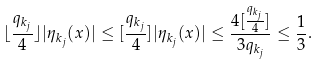Convert formula to latex. <formula><loc_0><loc_0><loc_500><loc_500>\lfloor \frac { q _ { k _ { j } } } { 4 } \rfloor | \eta _ { k _ { j } } ( x ) | \leq [ \frac { q _ { k _ { j } } } { 4 } ] | \eta _ { k _ { j } } ( x ) | \leq \frac { 4 [ \frac { q _ { k _ { j } } } { 4 } ] } { 3 q _ { k _ { j } } } \leq \frac { 1 } { 3 } .</formula> 